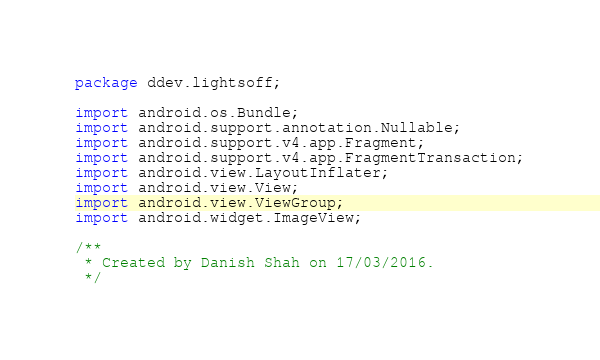Convert code to text. <code><loc_0><loc_0><loc_500><loc_500><_Java_>package ddev.lightsoff;

import android.os.Bundle;
import android.support.annotation.Nullable;
import android.support.v4.app.Fragment;
import android.support.v4.app.FragmentTransaction;
import android.view.LayoutInflater;
import android.view.View;
import android.view.ViewGroup;
import android.widget.ImageView;

/**
 * Created by Danish Shah on 17/03/2016.
 */</code> 